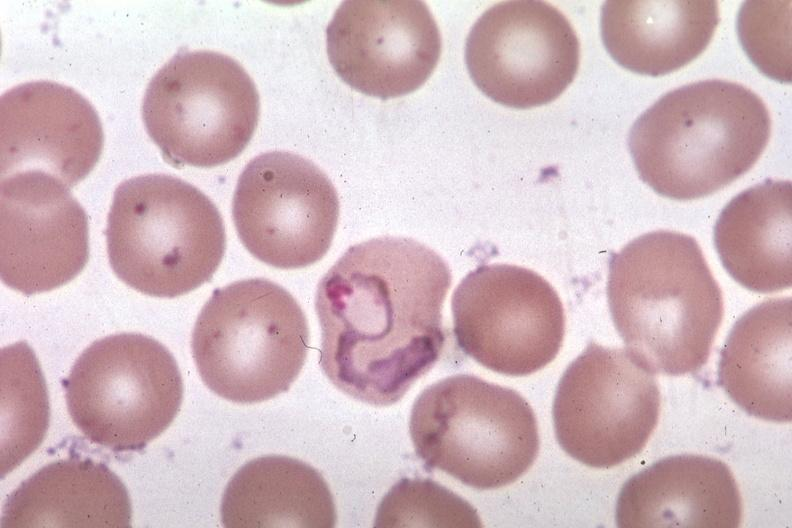what is present?
Answer the question using a single word or phrase. Malaria plasmodium vivax 